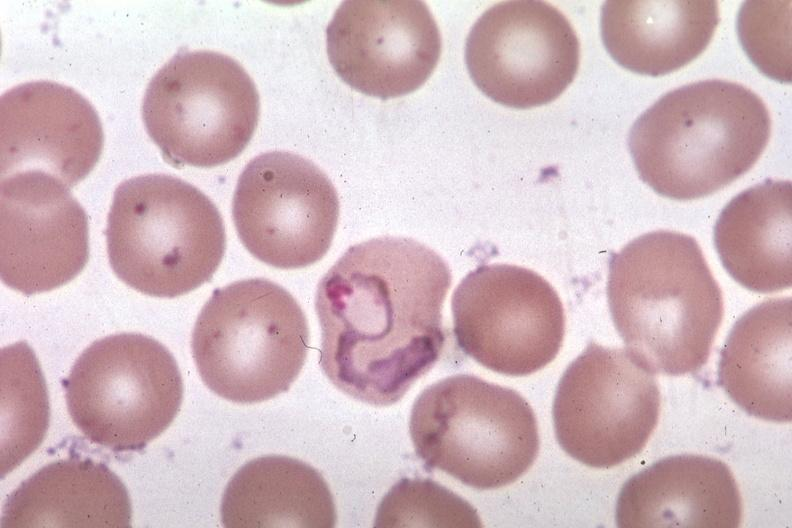what is present?
Answer the question using a single word or phrase. Malaria plasmodium vivax 